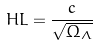Convert formula to latex. <formula><loc_0><loc_0><loc_500><loc_500>H L = \frac { c } { \sqrt { \Omega _ { \Lambda } } }</formula> 